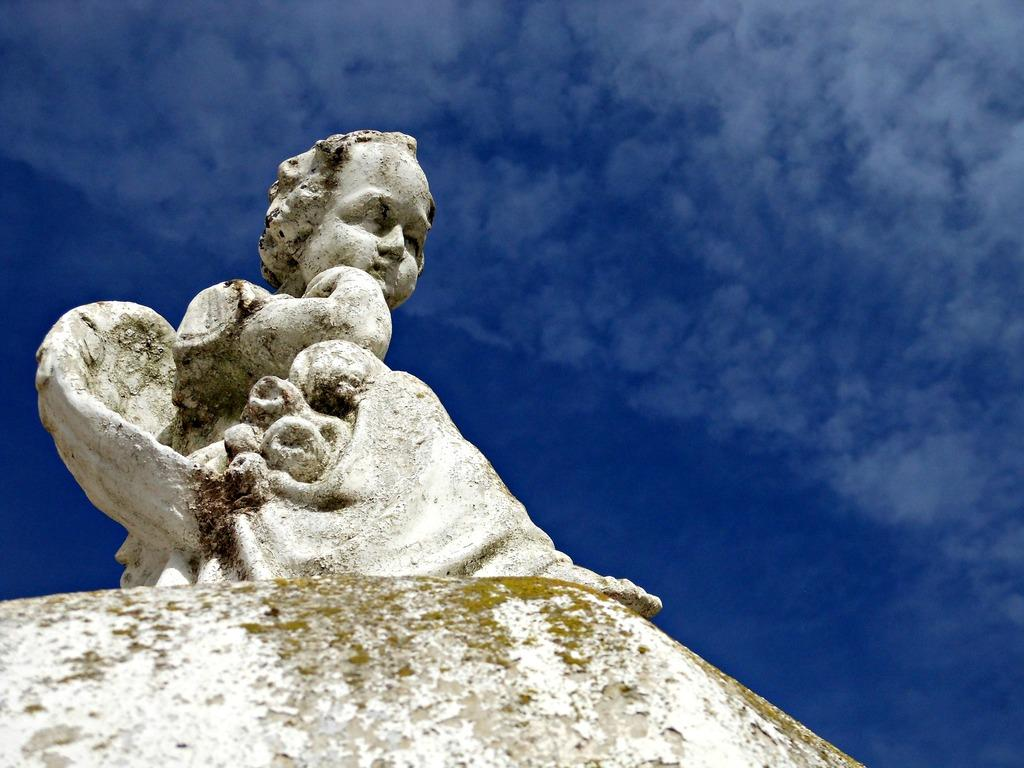What is the main subject in the foreground of the image? There is a sculpture in the foreground of the image. What can be seen in the background of the image? The sky is visible in the image. What is the weather like on the day the image was taken? It is a sunny day. What type of pie is being served on the table in the image? There is no table or pie present in the image; it features a sculpture and the sky. How many pancakes are stacked on the plate in the image? There are no pancakes or plates present in the image; it features a sculpture and the sky. 